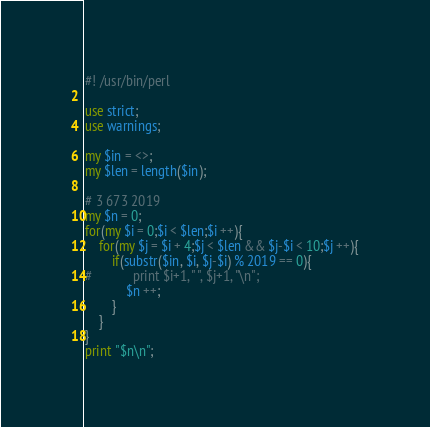Convert code to text. <code><loc_0><loc_0><loc_500><loc_500><_Perl_>#! /usr/bin/perl

use strict;
use warnings;

my $in = <>;
my $len = length($in);

# 3 673 2019
my $n = 0;
for(my $i = 0;$i < $len;$i ++){
    for(my $j = $i + 4;$j < $len && $j-$i < 10;$j ++){
        if(substr($in, $i, $j-$i) % 2019 == 0){
#            print $i+1, " ", $j+1, "\n";
            $n ++;
        }
    }
}
print "$n\n";
</code> 